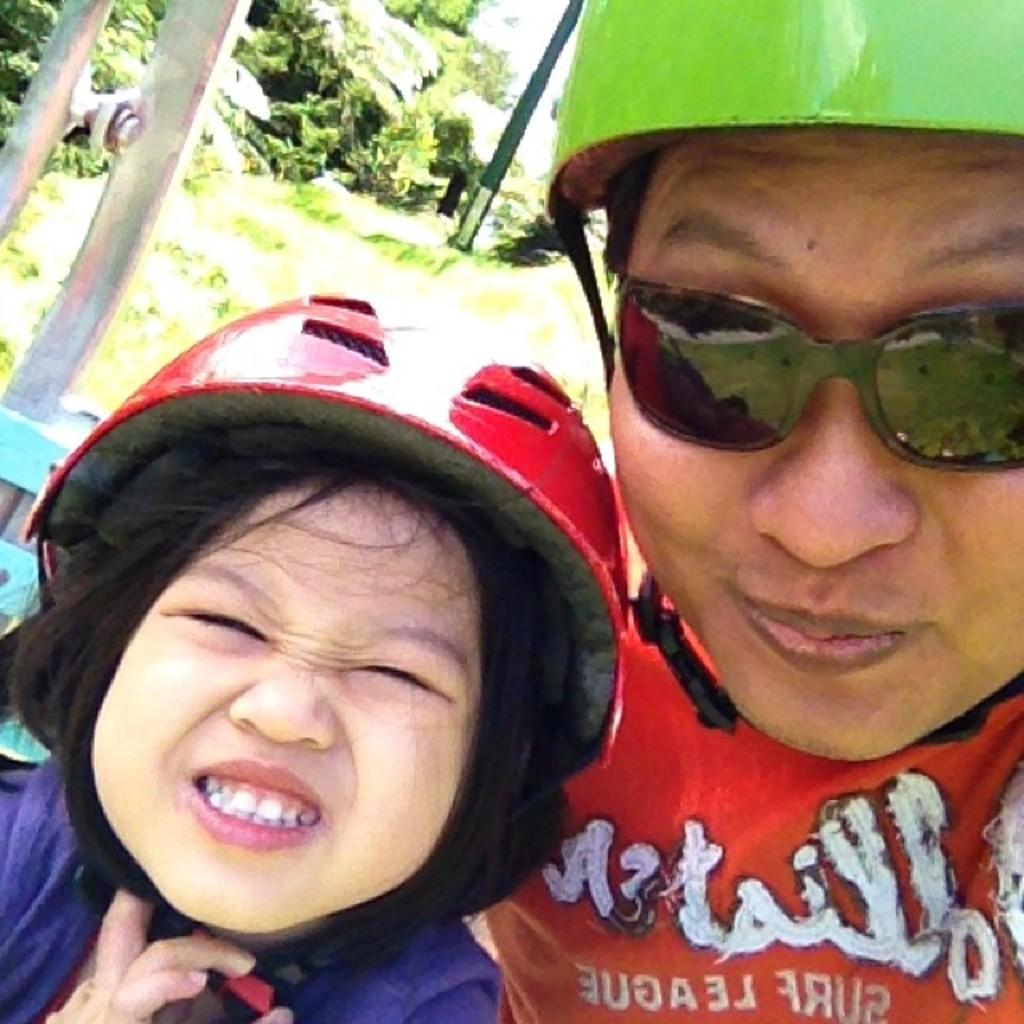What are the people in the image wearing on their heads? The people in the image are wearing helmets. What can be seen in the image that is tall and slender? There are poles visible in the image. What type of vegetation is present in the image? There are trees in the image. What type of suit is the insect wearing in the image? There is no insect present in the image, and therefore no suit can be observed. 